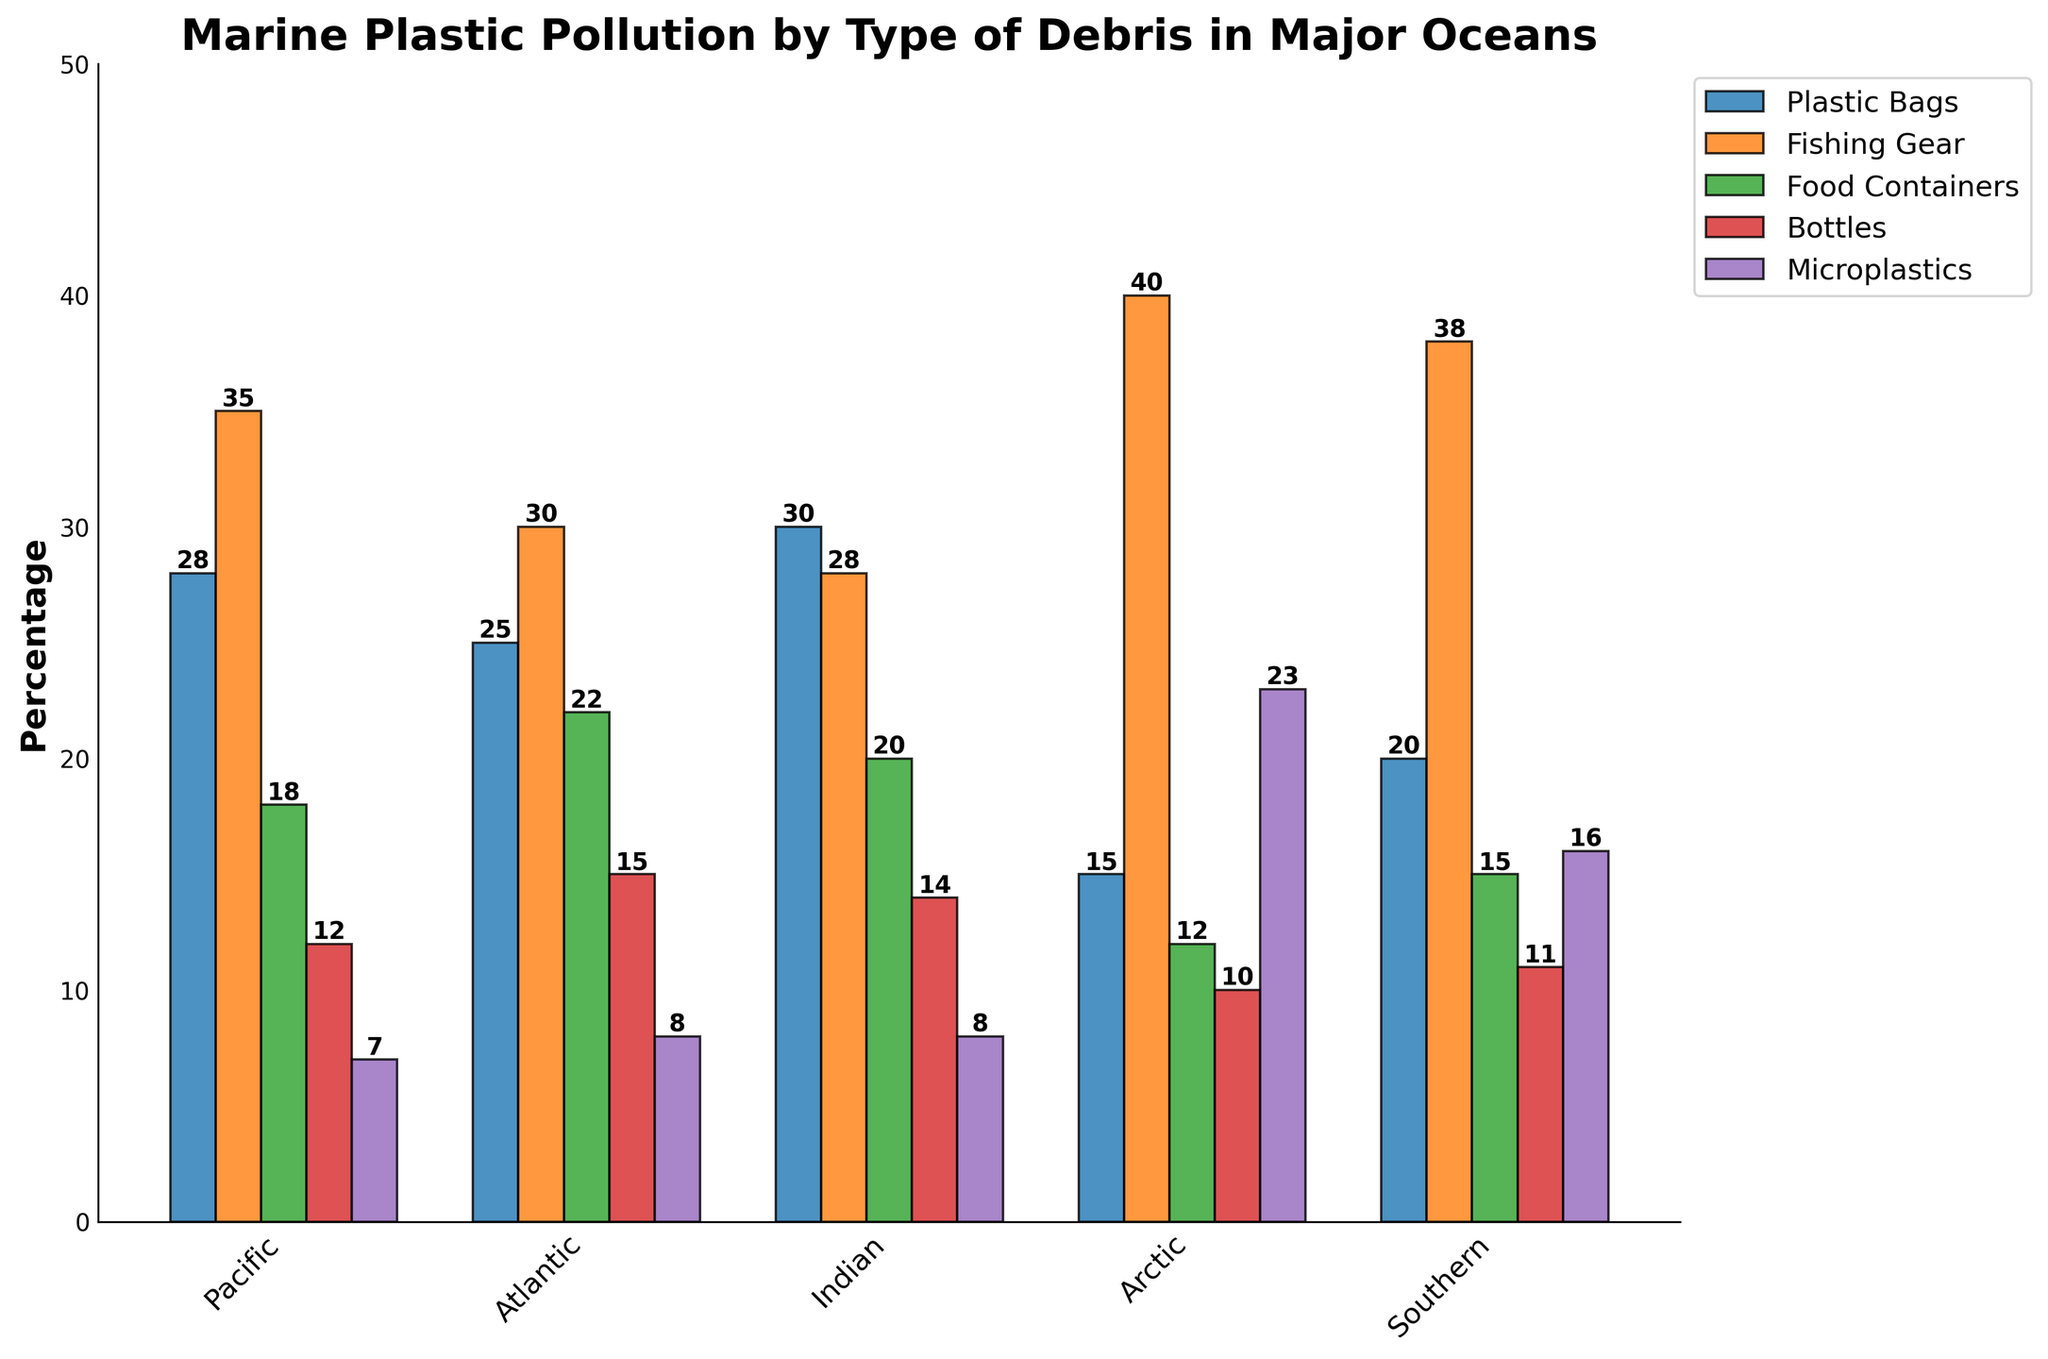What's the ocean with the highest percentage of Fishing Gear debris? To determine this, look for the tallest bar in the "Fishing Gear" section of the bar chart. According to the figure, the Arctic Ocean has the highest percentage.
Answer: Arctic Which type of debris has the highest percentage in the Southern Ocean? Look at the Southern Ocean bars and identify the tallest one. The tallest bar for the Southern Ocean represents Microplastics, which is 16%.
Answer: Microplastics What is the sum of Plastic Bags and Bottles debris percentages in the Pacific Ocean? Add the values for Plastic Bags (28) and Bottles (12) in the Pacific Ocean. The sum is 28 + 12 = 40.
Answer: 40 How does the percentage of Food Containers in the Indian Ocean compare to the Atlantic Ocean? Compare the height of the bars for Food Containers in both the Indian and Atlantic Oceans. The Indian Ocean has 20%, and the Atlantic Ocean has 22%. The Indian Ocean has fewer Food Containers than the Atlantic Ocean.
Answer: The Indian Ocean has fewer Which type of debris has a uniform percentage across the Atlantic and Indian Oceans? Compare the bar heights for each type of debris between the Atlantic and Indian Oceans. Microplastics both have a percentage of 8% in both oceans.
Answer: Microplastics What is the average percentage of Microplastics across all five oceans? Sum all the Microplastics values and divide by the number of oceans: (7 + 8 + 8 + 23 + 16) / 5 = 62 / 5 = 12.4.
Answer: 12.4 Comparing the Pacific and Arctic Oceans, which one has a higher percentage of Bottles debris? Look at the Bottles bar for both the Pacific and Arctic Oceans. The Pacific Ocean has 12%, and the Arctic Ocean has 10%. Therefore, the Pacific Ocean has a higher percentage.
Answer: Pacific What is the difference between the highest and lowest percentages of Food Containers across all oceans? Identify the highest (22% in the Atlantic) and lowest (12% in the Arctic) percentages of Food Containers and subtract the lowest from the highest: 22 - 12 = 10.
Answer: 10 What percentage of total debris is comprised of microplastics in the Arctic Ocean? The total percentage of debris in each ocean is the sum of all debris types. For the Arctic Ocean, this is 15 + 40 + 12 + 10 + 23 = 100. The percentage of microplastics is then (23 / 100) * 100 = 23%.
Answer: 23% 